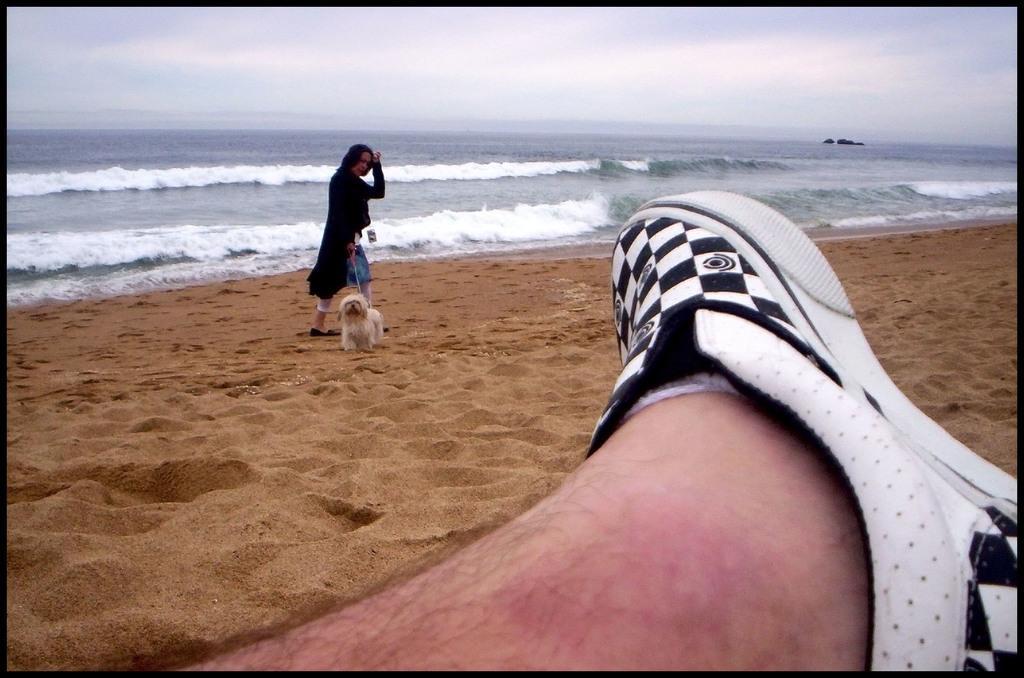In one or two sentences, can you explain what this image depicts? In this picture we can see the shoe and the leg of a person. We can see a woman holding a dog with a leash. There is the sand and waves are visible in the water. We can see the sky on top. 